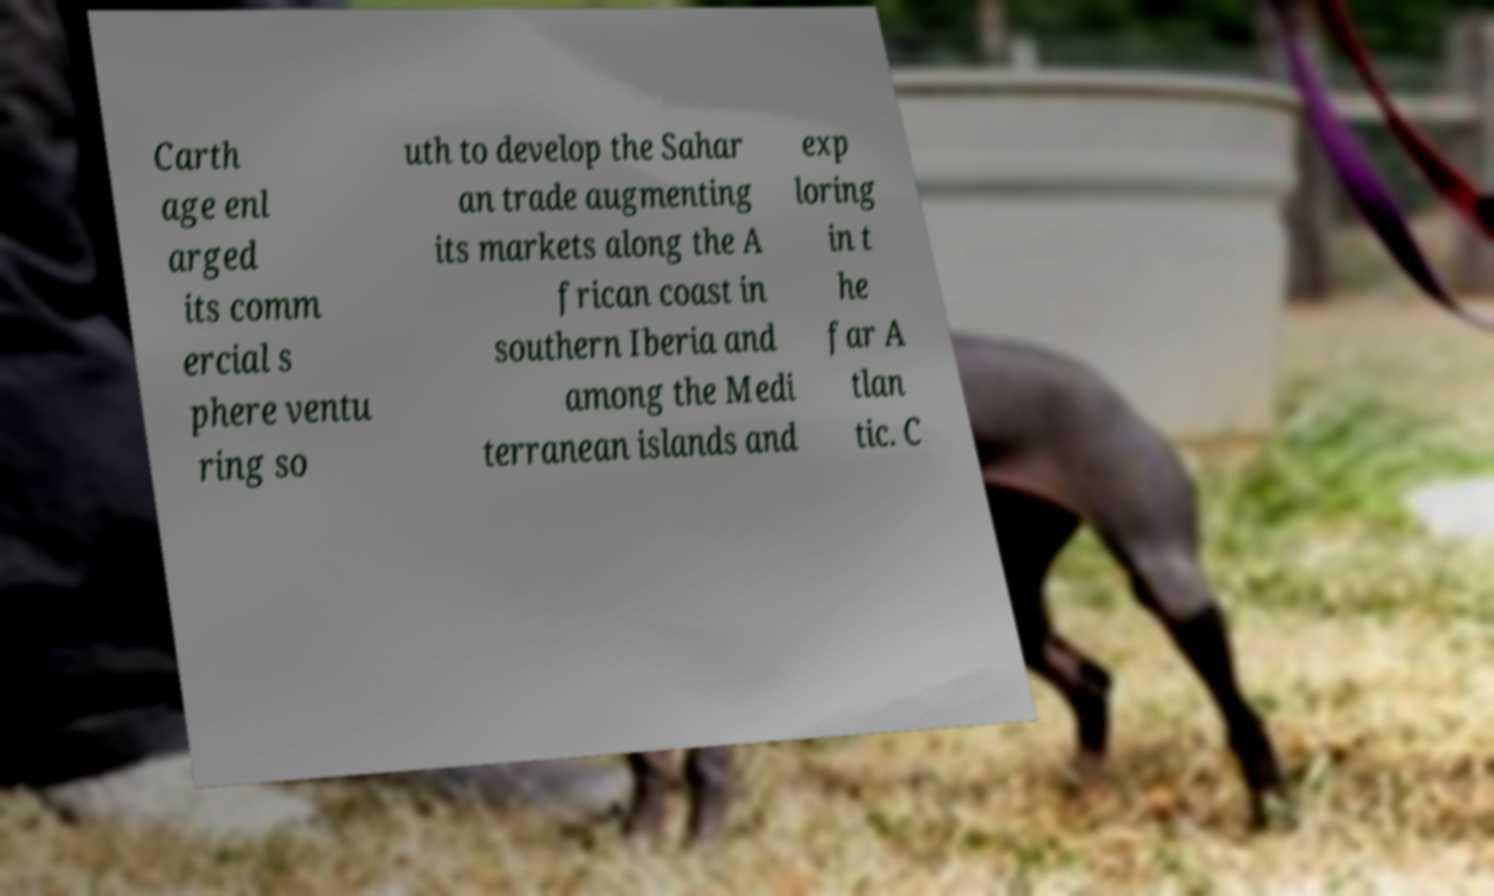For documentation purposes, I need the text within this image transcribed. Could you provide that? Carth age enl arged its comm ercial s phere ventu ring so uth to develop the Sahar an trade augmenting its markets along the A frican coast in southern Iberia and among the Medi terranean islands and exp loring in t he far A tlan tic. C 